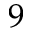Convert formula to latex. <formula><loc_0><loc_0><loc_500><loc_500>9</formula> 